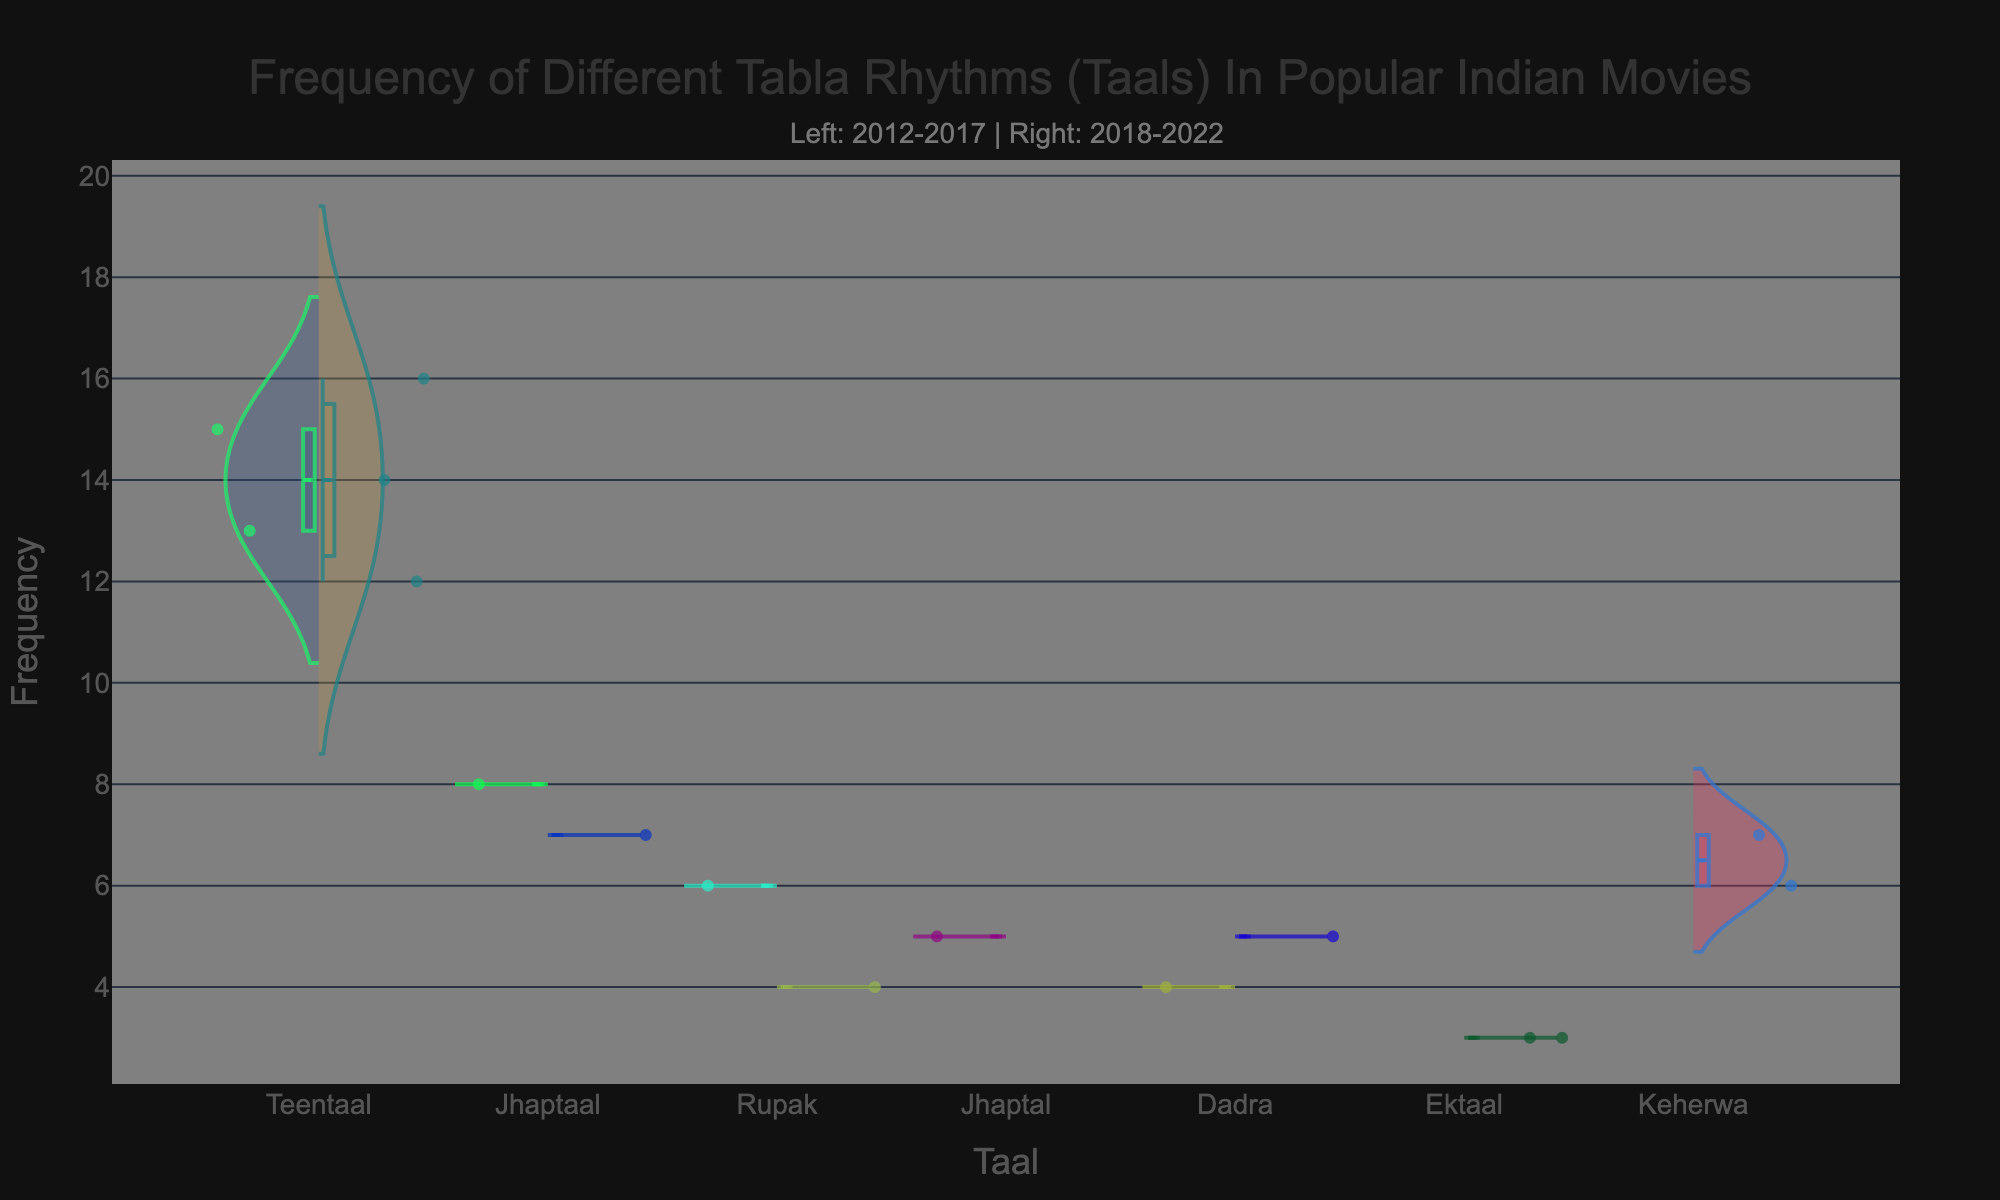Which Taal has the highest frequency on the right side of the chart? On the right side (years 2018-2022), locate the Taal with the highest peak. Teentaal reaches the highest value of 16.
Answer: Teentaal What is the overall frequency range of Teentaal from 2012 to 2022? Considering both sides of the chart, Teentaal ranges from its minimum of 12 to its maximum of 16. The frequency range is 16 - 12 = 4.
Answer: 4 Which Taal seems to have more presence in the earlier years (2012-2017)? Compare the violin plots to see which Taals have more instances on the left side. Teentaal exhibits more dense and higher frequency instances.
Answer: Teentaal What is the average frequency of Rupak in the later years (2018-2022)? For Rupak in the years 2018-2022, the frequencies are 4. The average frequency is (4) / 1 = 4.
Answer: 4 Which Taals are shown to have no change in frequency distribution between the two time periods? The Taals with identical violin plots on both sides are 'Ektaal'. The points are consistently at 3 on both sides.
Answer: Ektaal How many Taals show frequency in the range of 5 to 10 in the right side (2018-2022)? Check each Taal's right side for frequency values between 5 and 10. Jhaptaal and Keherwa fall within this range.
Answer: 2 (Jhaptaal, Keherwa) Are there any Taals that increased in frequency from the earlier years (2012-2017) to the later years (2018-2022)? Compare frequencies on both sides for each Taal to identify any increases. For Jhaptaal, the frequency increased from 8 to 14.
Answer: Yes (Jhaptaal) Which Taal has the lowest recorded frequency in the chart? Identify the minimum frequency value across all violin plots. The lowest frequency recorded is 3, seen in Ektaal and Brahmastra.
Answer: Ektaal Is there a Taal that is only present in the later years (2018-2022) but not in the earlier years (2012-2017)? Review the left (2012-2017) and right (2018-2022) sides to identify Taals exclusive to the right side. 'Brahmastra' appears in 2022 with 16 instances, exclusively on the right.
Answer: No 